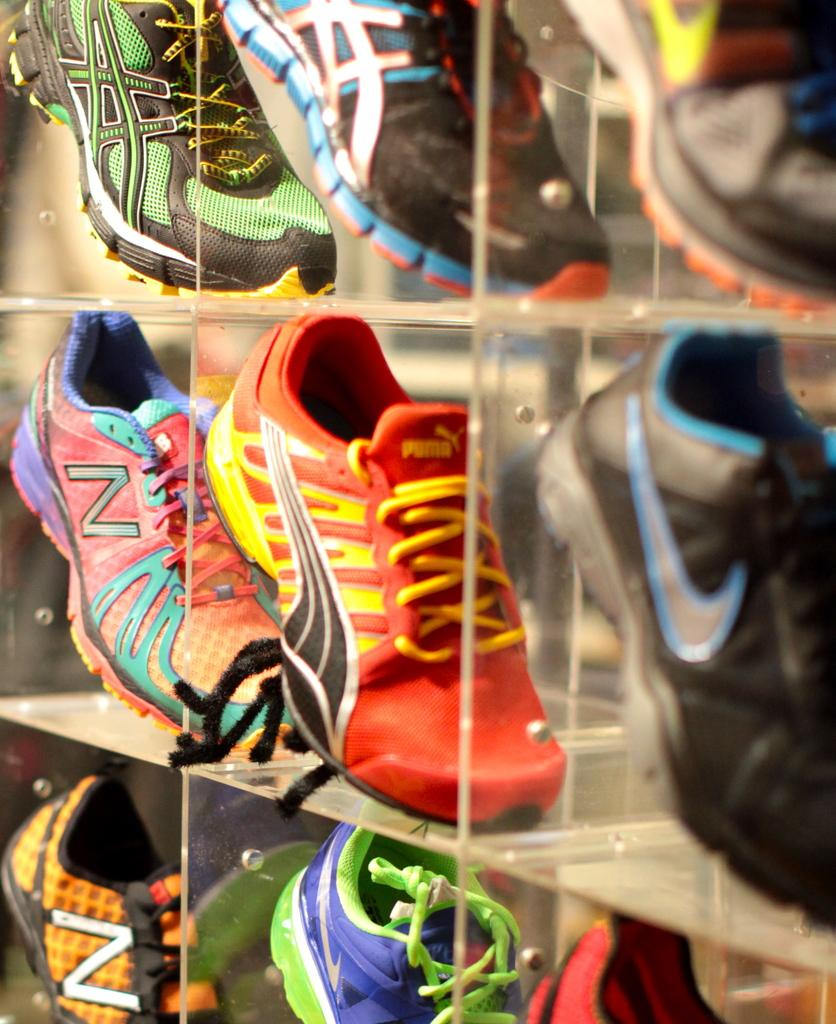What is the main object in the image? There is a rack in the image. What is placed on the rack? The rack has shoes on it. Can you describe the shoes on the rack? The shoes are of different colors. How does the rack show respect to the daughter in the image? There is no daughter or indication of respect in the image; it simply shows a rack with shoes on it. 